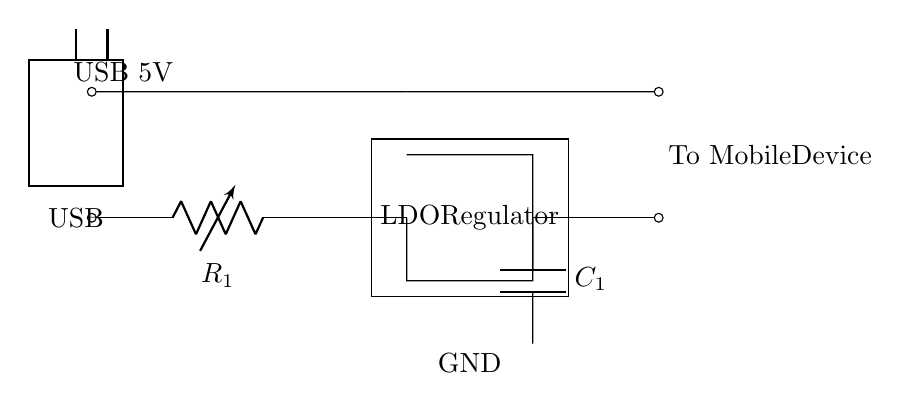What is the voltage input from the USB? The circuit indicates that the input voltage from the USB is 5V, as labeled in the diagram.
Answer: 5V What is the role of the LDO regulator in this circuit? The LDO (Low-Dropout) regulator functions to maintain a stable output voltage to the mobile device while allowing a small difference between input and output voltages.
Answer: Voltage regulation What type of capacitor is labeled in this circuit? The capacitor labeled as C1 in the circuit is an output capacitor, typically used to smooth the voltage provided to the device.
Answer: Output capacitor How many resistors are in the circuit? There is one resistor labeled R1 in the circuit, connecting the USB input to the voltage regulator.
Answer: One What is the purpose of the output to mobile device connection? This connection serves to deliver the regulated voltage from the circuit to the mobile device for charging.
Answer: To deliver power How is ground represented in this circuit? Ground is represented by the label at the bottom of the capacitor, indicating the reference point for the circuit's voltages.
Answer: At the bottom What does the symbol with the rectangle and two lines represent? The rectangle with lines above indicates a USB connector, which is the interface for input power into the circuit.
Answer: USB connector 